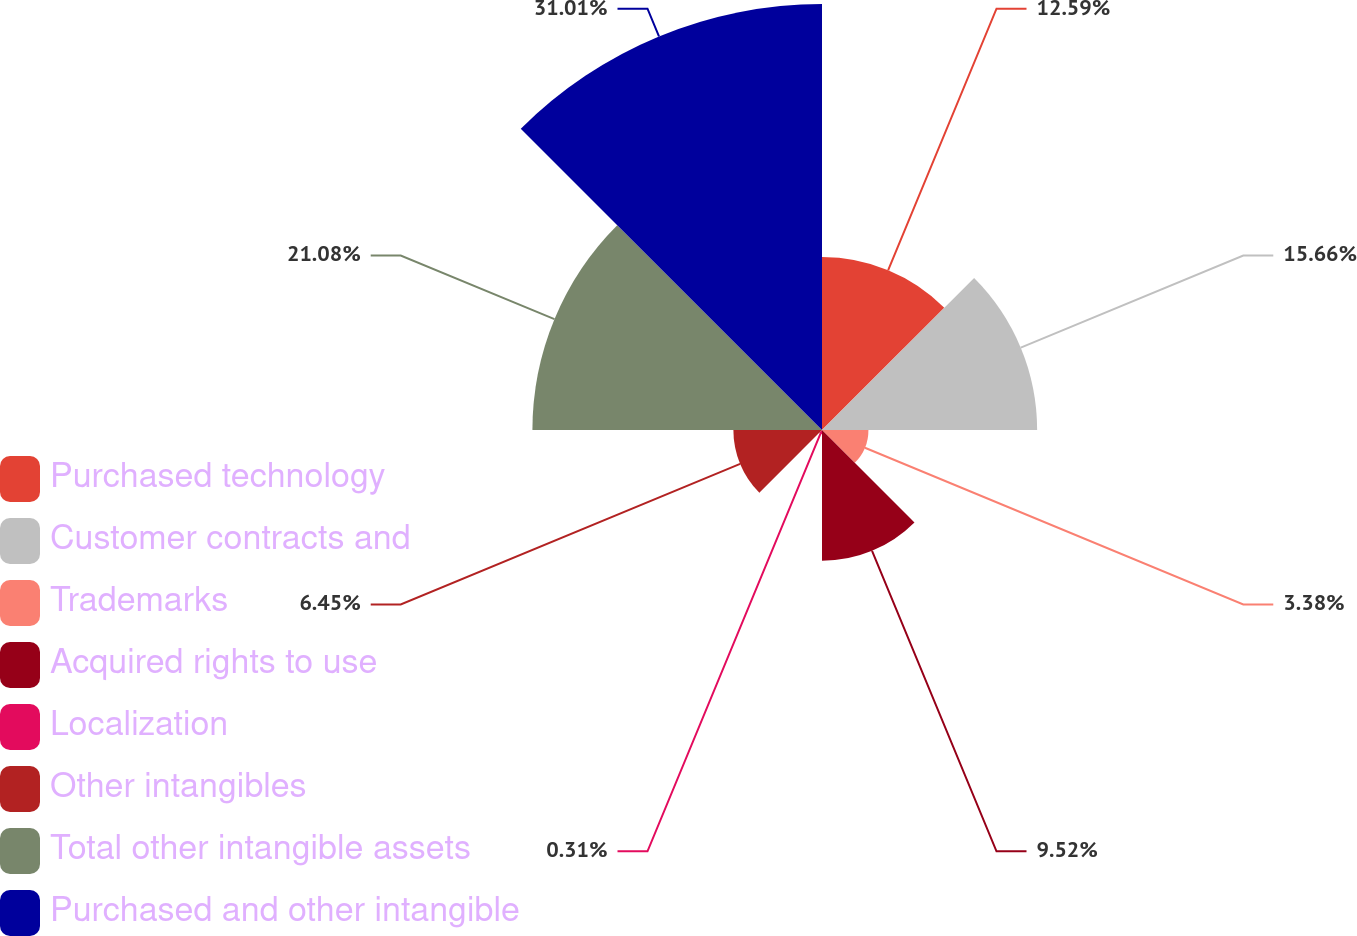<chart> <loc_0><loc_0><loc_500><loc_500><pie_chart><fcel>Purchased technology<fcel>Customer contracts and<fcel>Trademarks<fcel>Acquired rights to use<fcel>Localization<fcel>Other intangibles<fcel>Total other intangible assets<fcel>Purchased and other intangible<nl><fcel>12.59%<fcel>15.66%<fcel>3.38%<fcel>9.52%<fcel>0.31%<fcel>6.45%<fcel>21.08%<fcel>31.01%<nl></chart> 